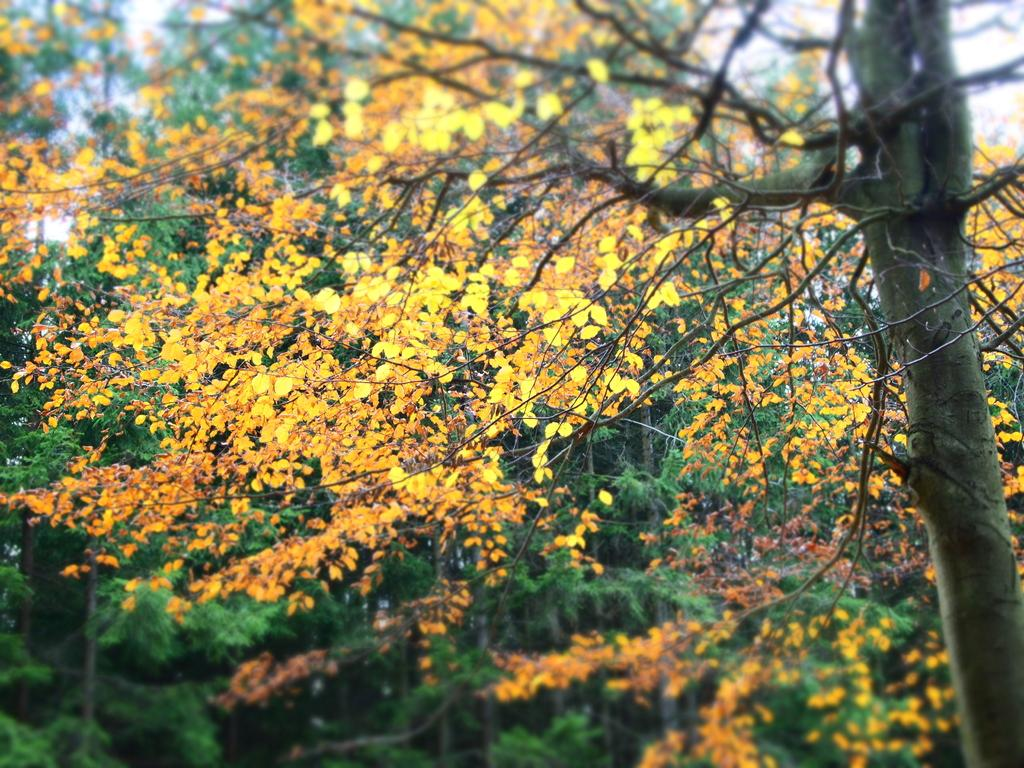What is the main feature of the center of the image? The center of the image contains the sky and trees. Can you describe the sky in the image? The sky is a prominent feature in the center of the image. What other elements are present in the center of the image besides the sky? Trees are present in the center of the image. How many apples are hanging from the trees in the image? There are no apples visible in the image; only trees and the sky are present. What type of order is being followed by the trees in the image? The trees in the image are not following any specific order; they are simply depicted as part of the natural landscape. 